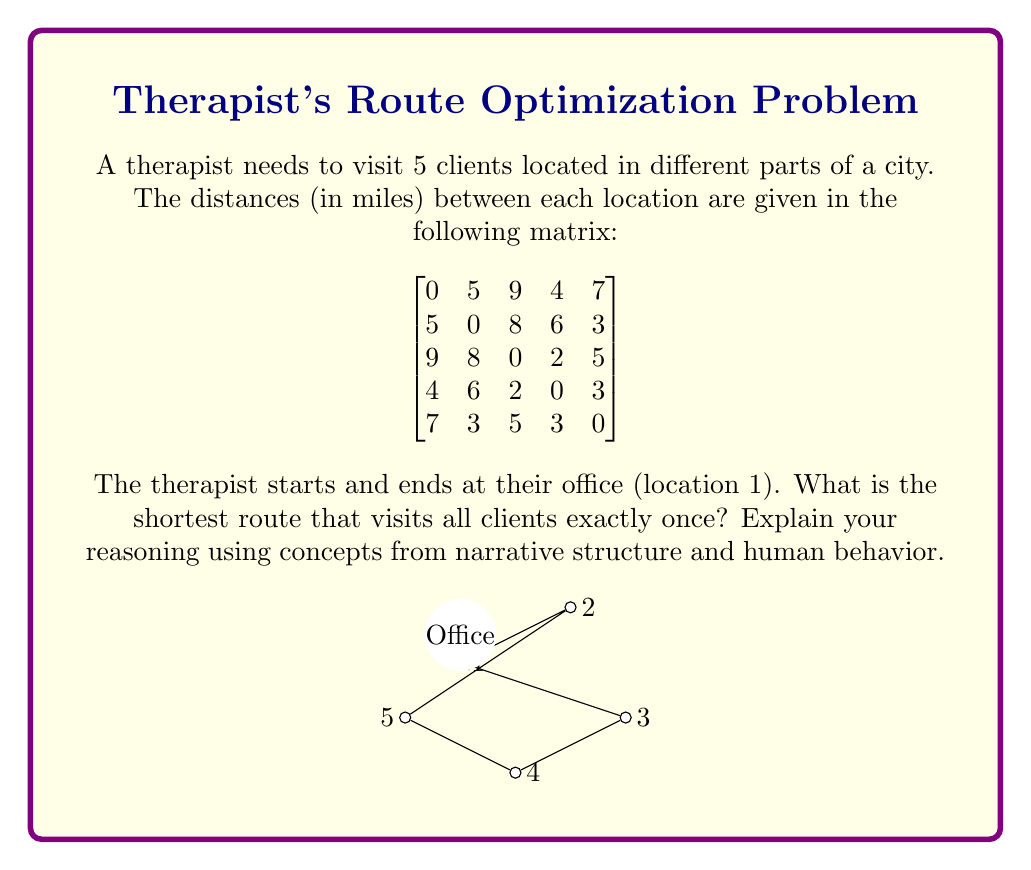Provide a solution to this math problem. To solve this problem, we can use the concept of the Traveling Salesman Problem (TSP), which aligns with the narrative structure of a hero's journey in storytelling:

1. Call to Adventure: The therapist (hero) leaves their office to visit clients.

2. Trials: Each client visit represents a challenge or subplot in the story.

3. Return: The therapist must return to the office, completing the circular narrative.

We can solve this using a simple heuristic method called the Nearest Neighbor algorithm, which mimics human decision-making in unfamiliar situations:

1. Start at the office (location 1).
2. Find the nearest unvisited location.
3. Move to that location.
4. Repeat steps 2-3 until all locations are visited.
5. Return to the office.

Let's apply this algorithm:

1. Start at location 1 (office)
2. Nearest to 1: location 4 (4 miles)
3. Nearest to 4: location 3 (2 miles)
4. Nearest to 3: location 5 (5 miles)
5. Only location 2 left (3 miles from 5)
6. Return to location 1 (5 miles from 2)

The total distance is:

$$4 + 2 + 5 + 3 + 5 = 19\text{ miles}$$

This solution represents a balance between efficiency (minimizing travel time) and the human tendency to make locally optimal choices, which aligns with the concept of bounded rationality in psychology.

While this may not always yield the globally optimal solution, it represents a realistic approach that a therapist might take when planning their route, considering cognitive limitations and the need for quick decision-making.
Answer: 1 → 4 → 3 → 5 → 2 → 1, total distance 19 miles 